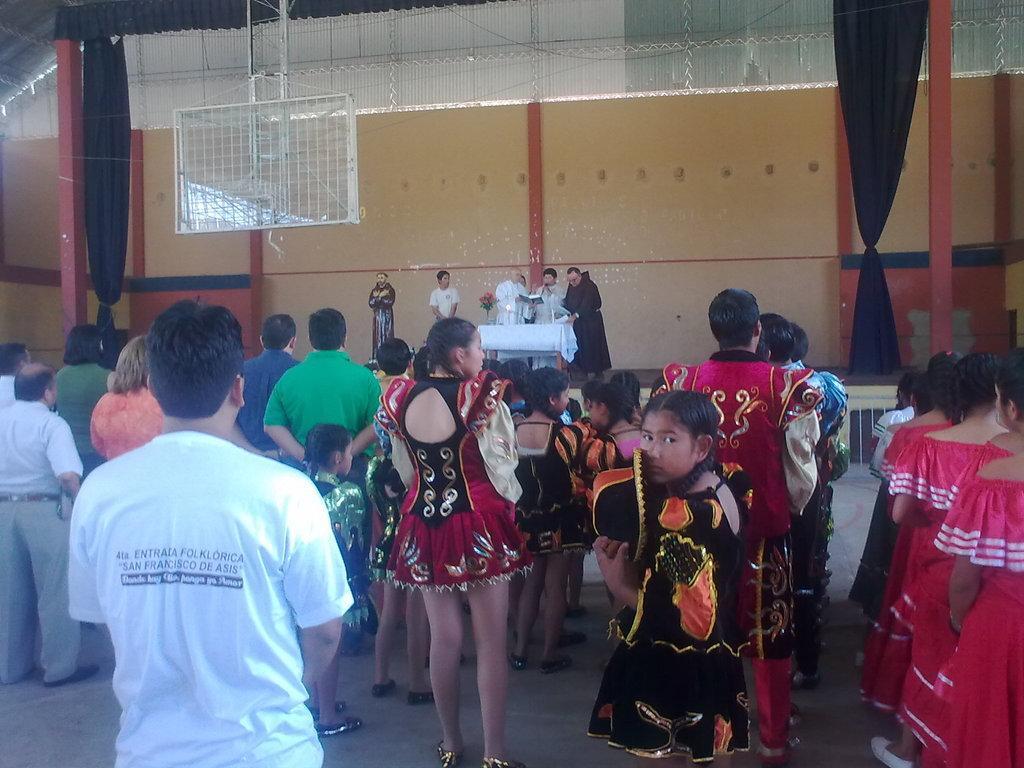Please provide a concise description of this image. In the picture I can see a group of people are standing on the floor. I can also see wall, a table which has flowers and a white color cloth covered on it. 